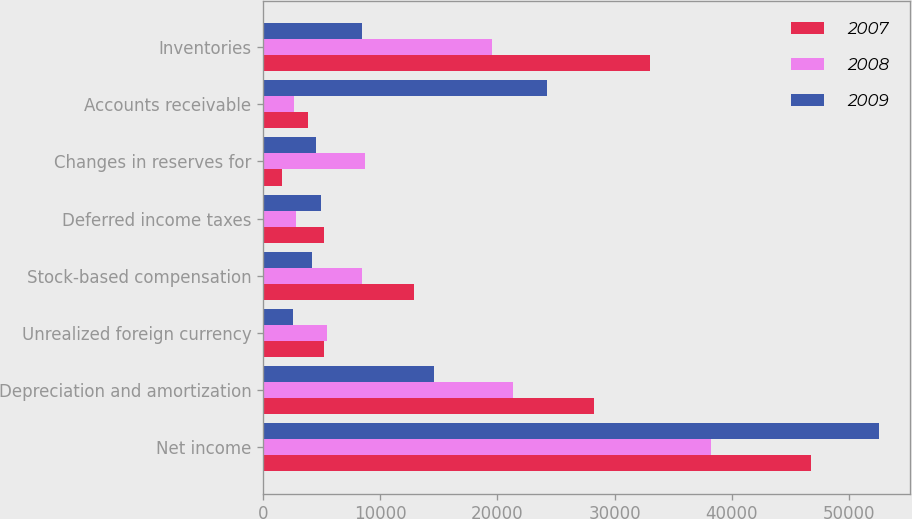Convert chart to OTSL. <chart><loc_0><loc_0><loc_500><loc_500><stacked_bar_chart><ecel><fcel>Net income<fcel>Depreciation and amortization<fcel>Unrealized foreign currency<fcel>Stock-based compensation<fcel>Deferred income taxes<fcel>Changes in reserves for<fcel>Accounts receivable<fcel>Inventories<nl><fcel>2007<fcel>46785<fcel>28249<fcel>5222<fcel>12910<fcel>5212<fcel>1623<fcel>3792<fcel>32998<nl><fcel>2008<fcel>38229<fcel>21347<fcel>5459<fcel>8466<fcel>2818<fcel>8711<fcel>2634<fcel>19497<nl><fcel>2009<fcel>52558<fcel>14622<fcel>2567<fcel>4182<fcel>4909<fcel>4551<fcel>24222<fcel>8466<nl></chart> 